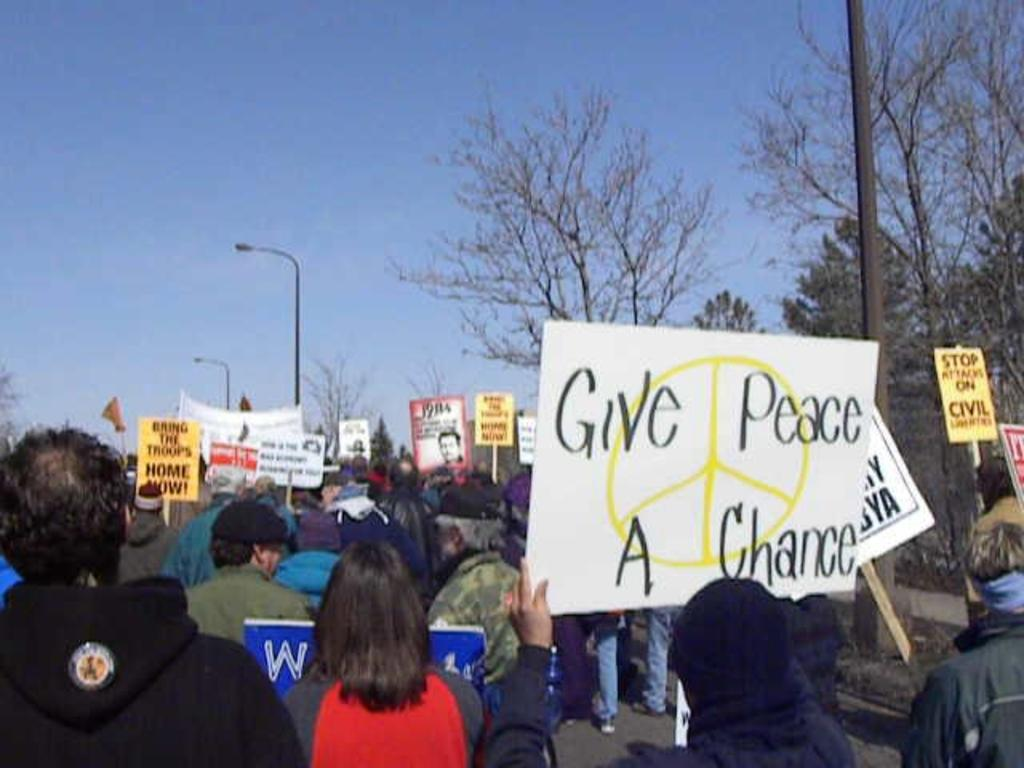<image>
Summarize the visual content of the image. A person holds up a sign that says Give Peace A Chance. 